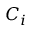<formula> <loc_0><loc_0><loc_500><loc_500>C _ { i }</formula> 